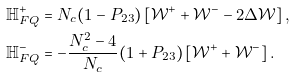<formula> <loc_0><loc_0><loc_500><loc_500>\mathbb { H } _ { F Q } ^ { + } & = N _ { c } ( 1 - P _ { 2 3 } ) \left [ \mathcal { W } ^ { + } + \mathcal { W } ^ { - } - 2 \Delta \mathcal { W } \right ] , \\ \mathbb { H } _ { F Q } ^ { - } & = - \frac { N _ { c } ^ { 2 } - 4 } { N _ { c } } ( 1 + P _ { 2 3 } ) \left [ \mathcal { W } ^ { + } + \mathcal { W } ^ { - } \right ] .</formula> 